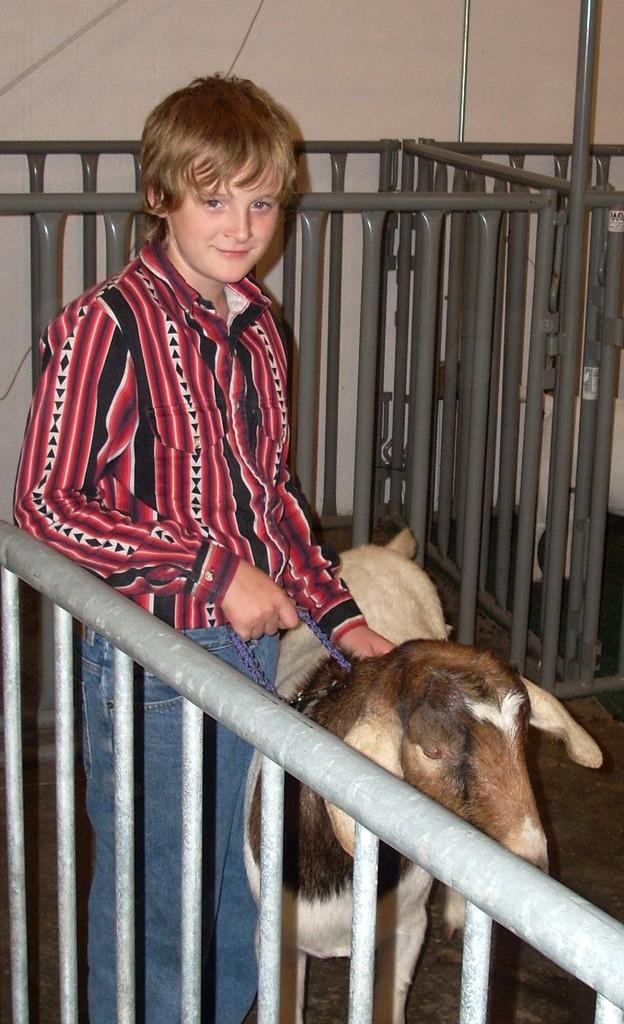How would you summarize this image in a sentence or two? In this image there is a person standing, he is truncated towards the bottom of the image, he is holding a leash, there is a goat truncated towards the bottom of the image, there is a fencing truncated towards the bottom of the image, there is a fencing at the back of the person, at the background of the image there is the wall truncated, there is a wire truncated towards the top of the image, there is an object truncated towards the top of the image, there is a fencing truncated towards the right of the image. 